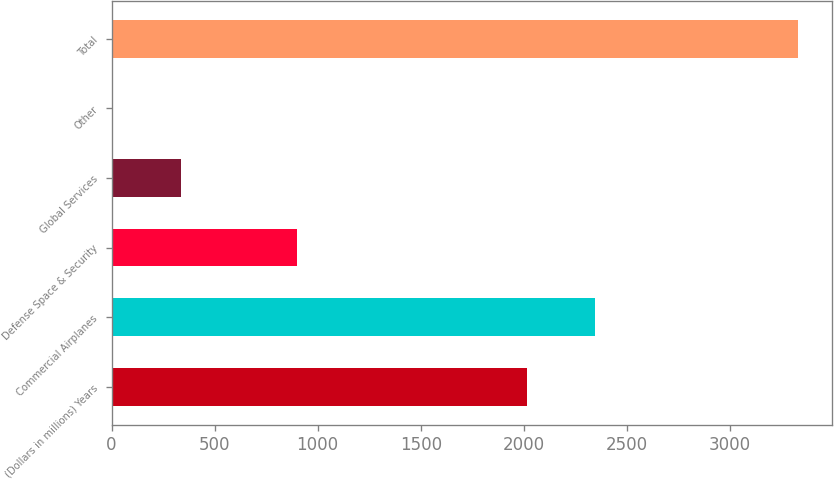Convert chart to OTSL. <chart><loc_0><loc_0><loc_500><loc_500><bar_chart><fcel>(Dollars in millions) Years<fcel>Commercial Airplanes<fcel>Defense Space & Security<fcel>Global Services<fcel>Other<fcel>Total<nl><fcel>2015<fcel>2347.6<fcel>902<fcel>337.6<fcel>5<fcel>3331<nl></chart> 